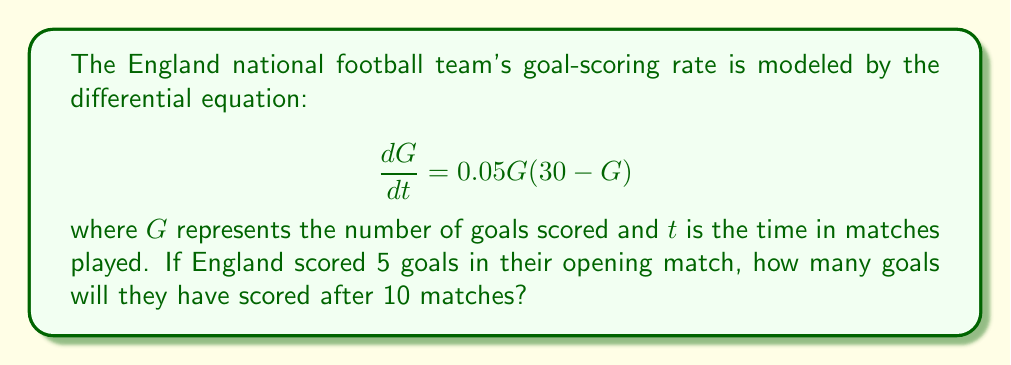Could you help me with this problem? To solve this problem, we need to use the given first-order differential equation and apply the separation of variables method.

1) First, we rearrange the equation:
   $$\frac{dG}{G(30 - G)} = 0.05dt$$

2) Integrate both sides:
   $$\int \frac{dG}{G(30 - G)} = \int 0.05dt$$

3) The left side can be integrated using partial fractions:
   $$\frac{1}{30}\left(\ln|G| - \ln|30-G|\right) = 0.05t + C$$

4) Simplify:
   $$\ln\left|\frac{G}{30-G}\right| = 1.5t + C$$

5) Exponentiate both sides:
   $$\frac{G}{30-G} = Ae^{1.5t}$$, where $A = e^C$

6) Solve for $G$:
   $$G = \frac{30Ae^{1.5t}}{1 + Ae^{1.5t}}$$

7) Use the initial condition: $G(0) = 5$ to find $A$:
   $$5 = \frac{30A}{1 + A}$$
   $$A = \frac{1}{5}$$

8) Our final solution is:
   $$G(t) = \frac{30(0.2)e^{1.5t}}{1 + (0.2)e^{1.5t}} = \frac{6e^{1.5t}}{1 + 0.2e^{1.5t}}$$

9) To find $G(10)$, we substitute $t = 10$:
   $$G(10) = \frac{6e^{15}}{1 + 0.2e^{15}} \approx 29.9999$$

Therefore, after 10 matches, England will have scored approximately 30 goals.
Answer: 30 goals (rounded to the nearest whole number) 